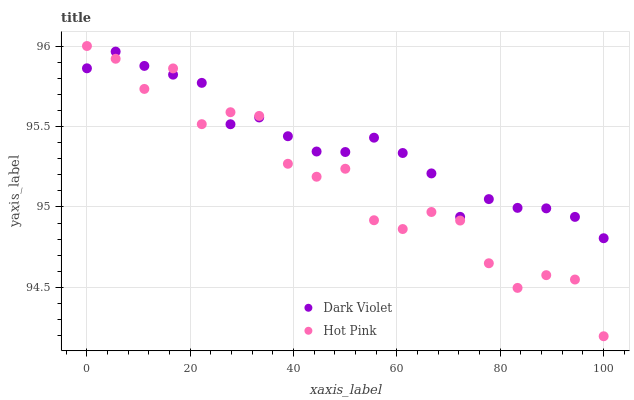Does Hot Pink have the minimum area under the curve?
Answer yes or no. Yes. Does Dark Violet have the maximum area under the curve?
Answer yes or no. Yes. Does Dark Violet have the minimum area under the curve?
Answer yes or no. No. Is Dark Violet the smoothest?
Answer yes or no. Yes. Is Hot Pink the roughest?
Answer yes or no. Yes. Is Dark Violet the roughest?
Answer yes or no. No. Does Hot Pink have the lowest value?
Answer yes or no. Yes. Does Dark Violet have the lowest value?
Answer yes or no. No. Does Hot Pink have the highest value?
Answer yes or no. Yes. Does Dark Violet have the highest value?
Answer yes or no. No. Does Dark Violet intersect Hot Pink?
Answer yes or no. Yes. Is Dark Violet less than Hot Pink?
Answer yes or no. No. Is Dark Violet greater than Hot Pink?
Answer yes or no. No. 